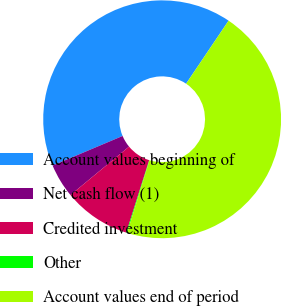<chart> <loc_0><loc_0><loc_500><loc_500><pie_chart><fcel>Account values beginning of<fcel>Net cash flow (1)<fcel>Credited investment<fcel>Other<fcel>Account values end of period<nl><fcel>40.8%<fcel>4.63%<fcel>9.13%<fcel>0.12%<fcel>45.31%<nl></chart> 